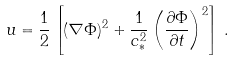Convert formula to latex. <formula><loc_0><loc_0><loc_500><loc_500>u = \frac { 1 } { 2 } \left [ ( \nabla \Phi ) ^ { 2 } + \frac { 1 } { c _ { * } ^ { 2 } } \left ( \frac { \partial \Phi } { \partial t } \right ) ^ { 2 } \right ] \, .</formula> 